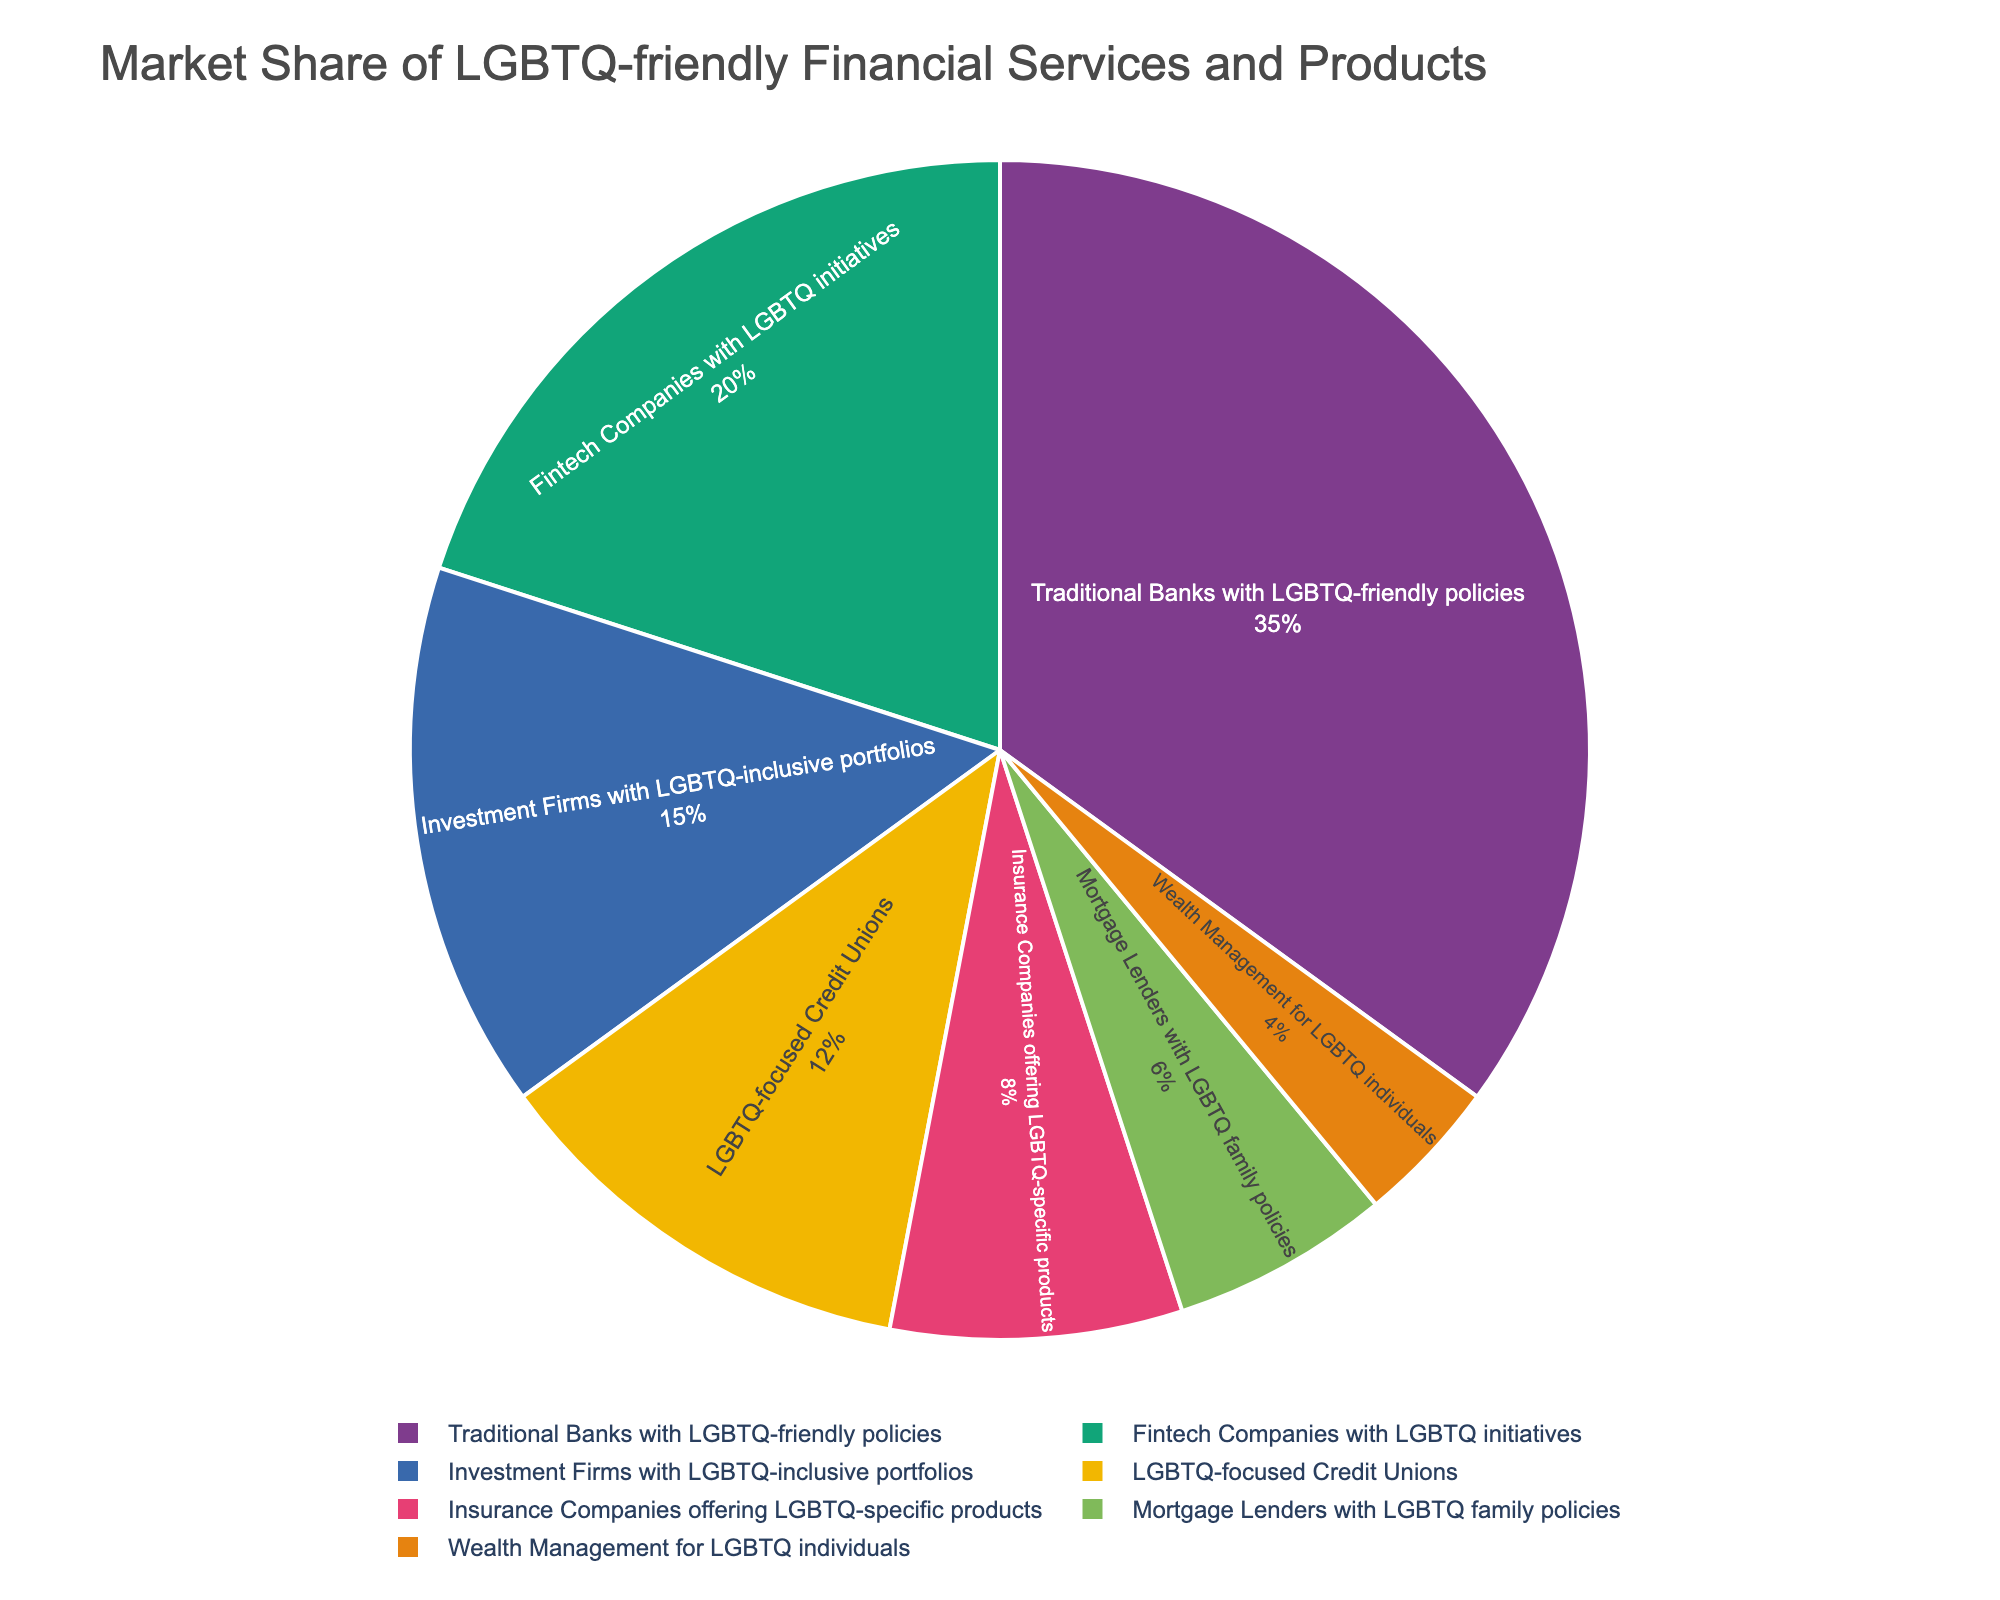What category has the largest market share in LGBTQ-friendly financial services? By looking at the pie chart, the largest segment corresponds to the category 'Traditional Banks with LGBTQ-friendly policies'.
Answer: Traditional Banks with LGBTQ-friendly policies What is the combined market share of Fintech Companies with LGBTQ initiatives and LGBTQ-focused Credit Unions? The pie chart shows 20% for Fintech Companies with LGBTQ initiatives and 12% for LGBTQ-focused Credit Unions. Summing these gives 20 + 12 = 32%.
Answer: 32% Which category has a smaller market share: Insurance Companies offering LGBTQ-specific products or Mortgage Lenders with LGBTQ family policies? From the pie chart, Insurance Companies have 8% and Mortgage Lenders have 6%. Since 6% is less than 8%, Mortgage Lenders have a smaller market share.
Answer: Mortgage Lenders What percentage of the market is represented by Wealth Management for LGBTQ individuals? The pie chart shows a small segment corresponding to Wealth Management for LGBTQ individuals, which is labeled with 4%.
Answer: 4% What is the difference in market share between Investment Firms with LGBTQ-inclusive portfolios and Mortgage Lenders with LGBTQ family policies? The pie chart shows Investment Firms with 15% and Mortgage Lenders with 6%. The difference is 15 - 6 = 9%.
Answer: 9% How does the market share of LGBTQ-focused Credit Unions compare to that of Insurance Companies offering LGBTQ-specific products? The pie chart shows that LGBTQ-focused Credit Unions have a market share of 12%, while Insurance Companies have 8%. Since 12% is greater than 8%, Credit Unions have a larger market share.
Answer: LGBTQ-focused Credit Unions have a larger market share Which two categories together make up exactly 20% of the market share? The pie chart segments show Insurance Companies offering LGBTQ-specific products with 8% and Mortgage Lenders with LGBTQ family policies with 6%, adding to 8 + 6 = 14%. Wealth Management for LGBTQ individuals adds another 4% to make 14 + 4 = 18%. Therefore, no exact 20% combination exists from the chart.
Answer: No exact combination Compare the visual sizes of the pie chart segments for Fintech Companies with LGBTQ initiatives and Wealth Management for LGBTQ individuals. Which segment appears larger and by how much? By examining the pie chart, we see that the Fintech Companies segment is much larger than the Wealth Management segment. Fintech companies have a share of 20% and Wealth Management has 4%, showing that the Fintech Companies' portion is visually 5 times larger (20% / 4% = 5).
Answer: Fintech Companies, 5 times larger 